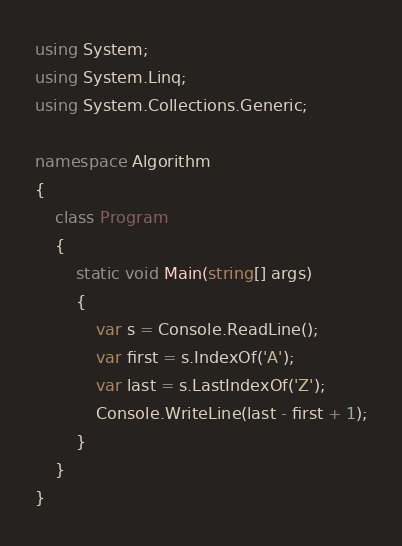Convert code to text. <code><loc_0><loc_0><loc_500><loc_500><_C#_>using System;
using System.Linq;
using System.Collections.Generic;

namespace Algorithm
{
    class Program
    {
        static void Main(string[] args)
        {
            var s = Console.ReadLine();
            var first = s.IndexOf('A');
            var last = s.LastIndexOf('Z');
            Console.WriteLine(last - first + 1);
        }
    }
}
</code> 